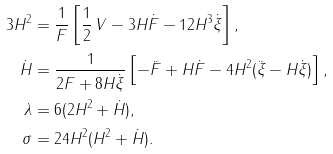Convert formula to latex. <formula><loc_0><loc_0><loc_500><loc_500>3 H ^ { 2 } & = \frac { 1 } { F } \left [ \frac { 1 } { 2 } \, V - 3 H { \dot { F } } - 1 2 H ^ { 3 } { \dot { \xi } } \right ] , \\ { \dot { H } } & = \frac { 1 } { 2 F + 8 H { \dot { \xi } } } \left [ - { \ddot { F } } + H { \dot { F } } - 4 H ^ { 2 } ( { \ddot { \xi } } - H { \dot { \xi } } ) \right ] , \\ \lambda & = 6 ( 2 H ^ { 2 } + { \dot { H } } ) , \\ \sigma & = 2 4 H ^ { 2 } ( H ^ { 2 } + { \dot { H } } ) .</formula> 